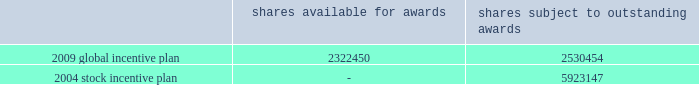Tax returns for 2001 and beyond are open for examination under statute .
Currently , unrecognized tax benefits are not expected to change significantly over the next 12 months .
19 .
Stock-based and other management compensation plans in april 2009 , the company approved a global incentive plan which replaces the company 2019s 2004 stock incentive plan .
The 2009 global incentive plan ( 201cgip 201d ) enables the compensation committee of the board of directors to award incentive and nonqualified stock options , stock appreciation rights , shares of series a common stock , restricted stock , restricted stock units ( 201crsus 201d ) and incentive bonuses ( which may be paid in cash or stock or a combination thereof ) , any of which may be performance-based , with vesting and other award provisions that provide effective incentive to company employees ( including officers ) , non-management directors and other service providers .
Under the 2009 gip , the company no longer can grant rsus with the right to participate in dividends or dividend equivalents .
The maximum number of shares that may be issued under the 2009 gip is equal to 5350000 shares plus ( a ) any shares of series a common stock that remain available for issuance under the 2004 stock incentive plan ( 201csip 201d ) ( not including any shares of series a common stock that are subject to outstanding awards under the 2004 sip or any shares of series a common stock that were issued pursuant to awards under the 2004 sip ) and ( b ) any awards under the 2004 stock incentive plan that remain outstanding that cease for any reason to be subject to such awards ( other than by reason of exercise or settlement of the award to the extent that such award is exercised for or settled in vested and non-forfeitable shares ) .
As of december 31 , 2010 , total shares available for awards and total shares subject to outstanding awards are as follows : shares available for awards shares subject to outstanding awards .
Upon the termination of a participant 2019s employment with the company by reason of death or disability or by the company without cause ( as defined in the respective award agreements ) , an award in amount equal to ( i ) the value of the award granted multiplied by ( ii ) a fraction , ( x ) the numerator of which is the number of full months between grant date and the date of such termination , and ( y ) the denominator of which is the term of the award , such product to be rounded down to the nearest whole number , and reduced by ( iii ) the value of any award that previously vested , shall immediately vest and become payable to the participant .
Upon the termination of a participant 2019s employment with the company for any other reason , any unvested portion of the award shall be forfeited and cancelled without consideration .
There was $ 19 million and $ 0 million of tax benefit realized from stock option exercises and vesting of rsus during the years ended december 31 , 2010 and 2009 , respectively .
During the year ended december 31 , 2008 the company reversed $ 8 million of the $ 19 million tax benefit that was realized during the year ended december 31 , 2007 .
Deferred compensation in april 2007 , certain participants in the company 2019s 2004 deferred compensation plan elected to participate in a revised program , which includes both cash awards and restricted stock units ( see restricted stock units below ) .
Based on participation in the revised program , the company expensed $ 9 million , $ 10 million and $ 8 million during the years ended december 31 , 2010 , 2009 and 2008 , respectively , related to the revised program and made payments of $ 4 million during the year ended december 31 , 2010 to participants who left the company and $ 28 million to active employees during december 2010 .
As of december 31 , 2010 , $ 1 million remains to be paid during 2011 under the revised program .
As of december 31 , 2009 , there was no deferred compensation payable remaining associated with the 2004 deferred compensation plan .
The company recorded expense related to participants continuing in the 2004 deferred %%transmsg*** transmitting job : d77691 pcn : 132000000 ***%%pcmsg|132 |00011|yes|no|02/09/2011 18:22|0|0|page is valid , no graphics -- color : n| .
What portion of the total shares subject to outstanding awards is under the 2004 stock incentive plan? 
Computations: (2530454 / (2530454 + 5923147))
Answer: 0.29933. 